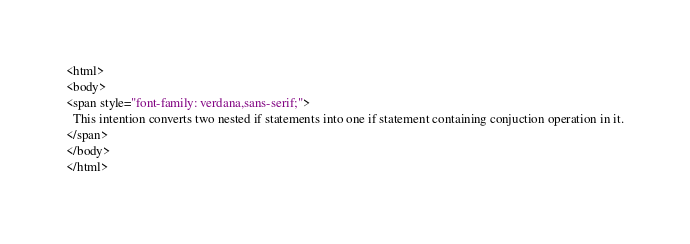Convert code to text. <code><loc_0><loc_0><loc_500><loc_500><_HTML_><html>
<body>
<span style="font-family: verdana,sans-serif;">
  This intention converts two nested if statements into one if statement containing conjuction operation in it.
</span>
</body>
</html></code> 